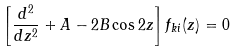<formula> <loc_0><loc_0><loc_500><loc_500>\left [ \frac { d ^ { 2 } } { d z ^ { 2 } } + A - 2 B \cos 2 z \right ] f _ { k i } ( z ) = 0</formula> 